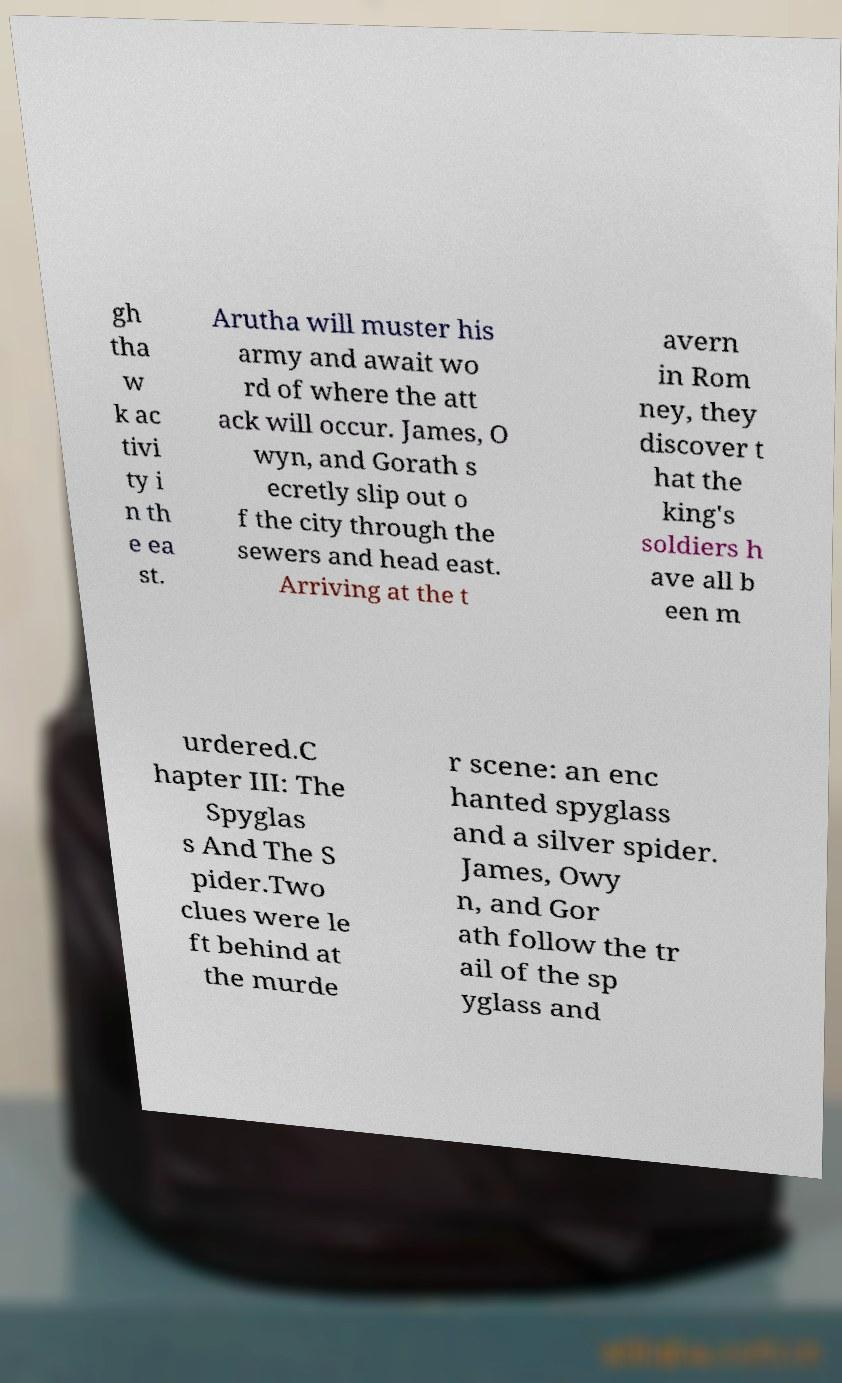Can you read and provide the text displayed in the image?This photo seems to have some interesting text. Can you extract and type it out for me? gh tha w k ac tivi ty i n th e ea st. Arutha will muster his army and await wo rd of where the att ack will occur. James, O wyn, and Gorath s ecretly slip out o f the city through the sewers and head east. Arriving at the t avern in Rom ney, they discover t hat the king's soldiers h ave all b een m urdered.C hapter III: The Spyglas s And The S pider.Two clues were le ft behind at the murde r scene: an enc hanted spyglass and a silver spider. James, Owy n, and Gor ath follow the tr ail of the sp yglass and 